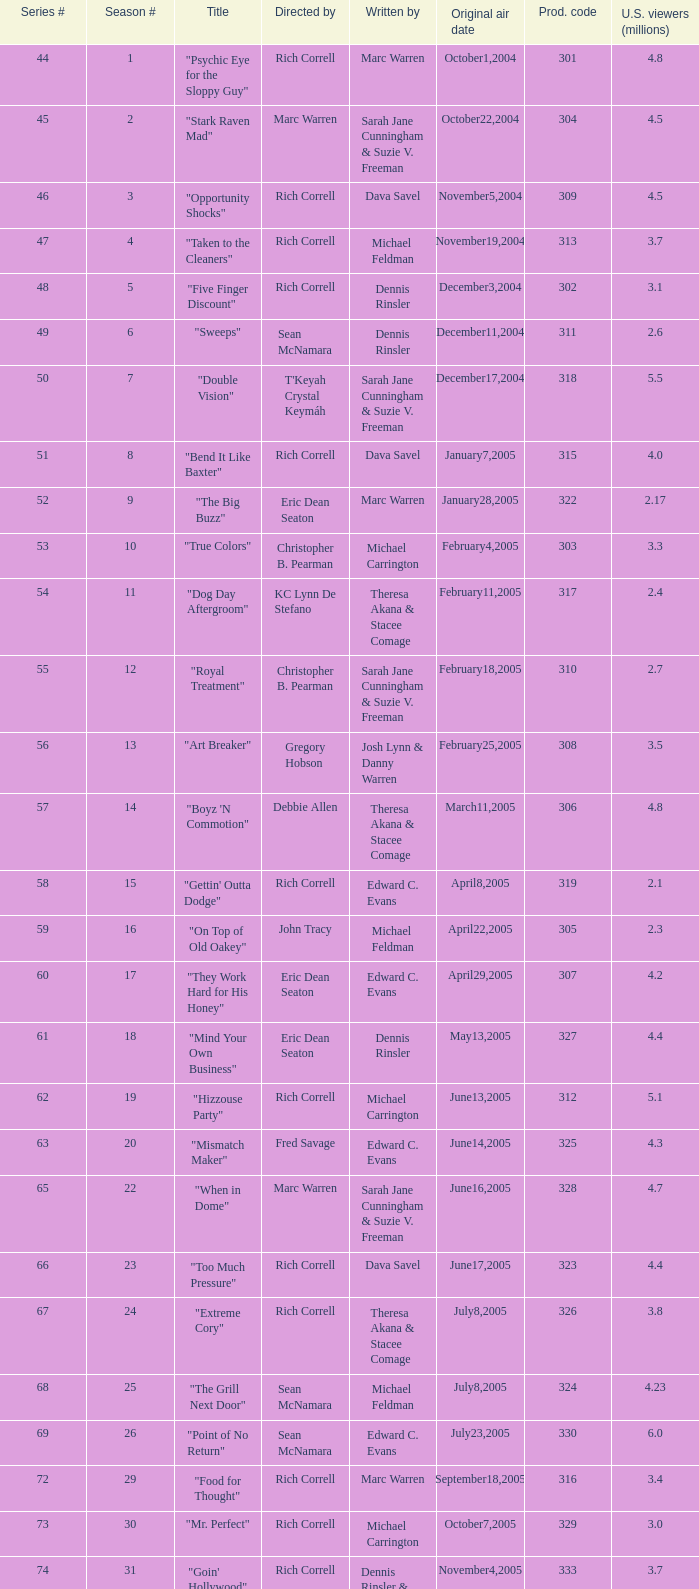What number episode of the season was titled "Vision Impossible"? 34.0. 